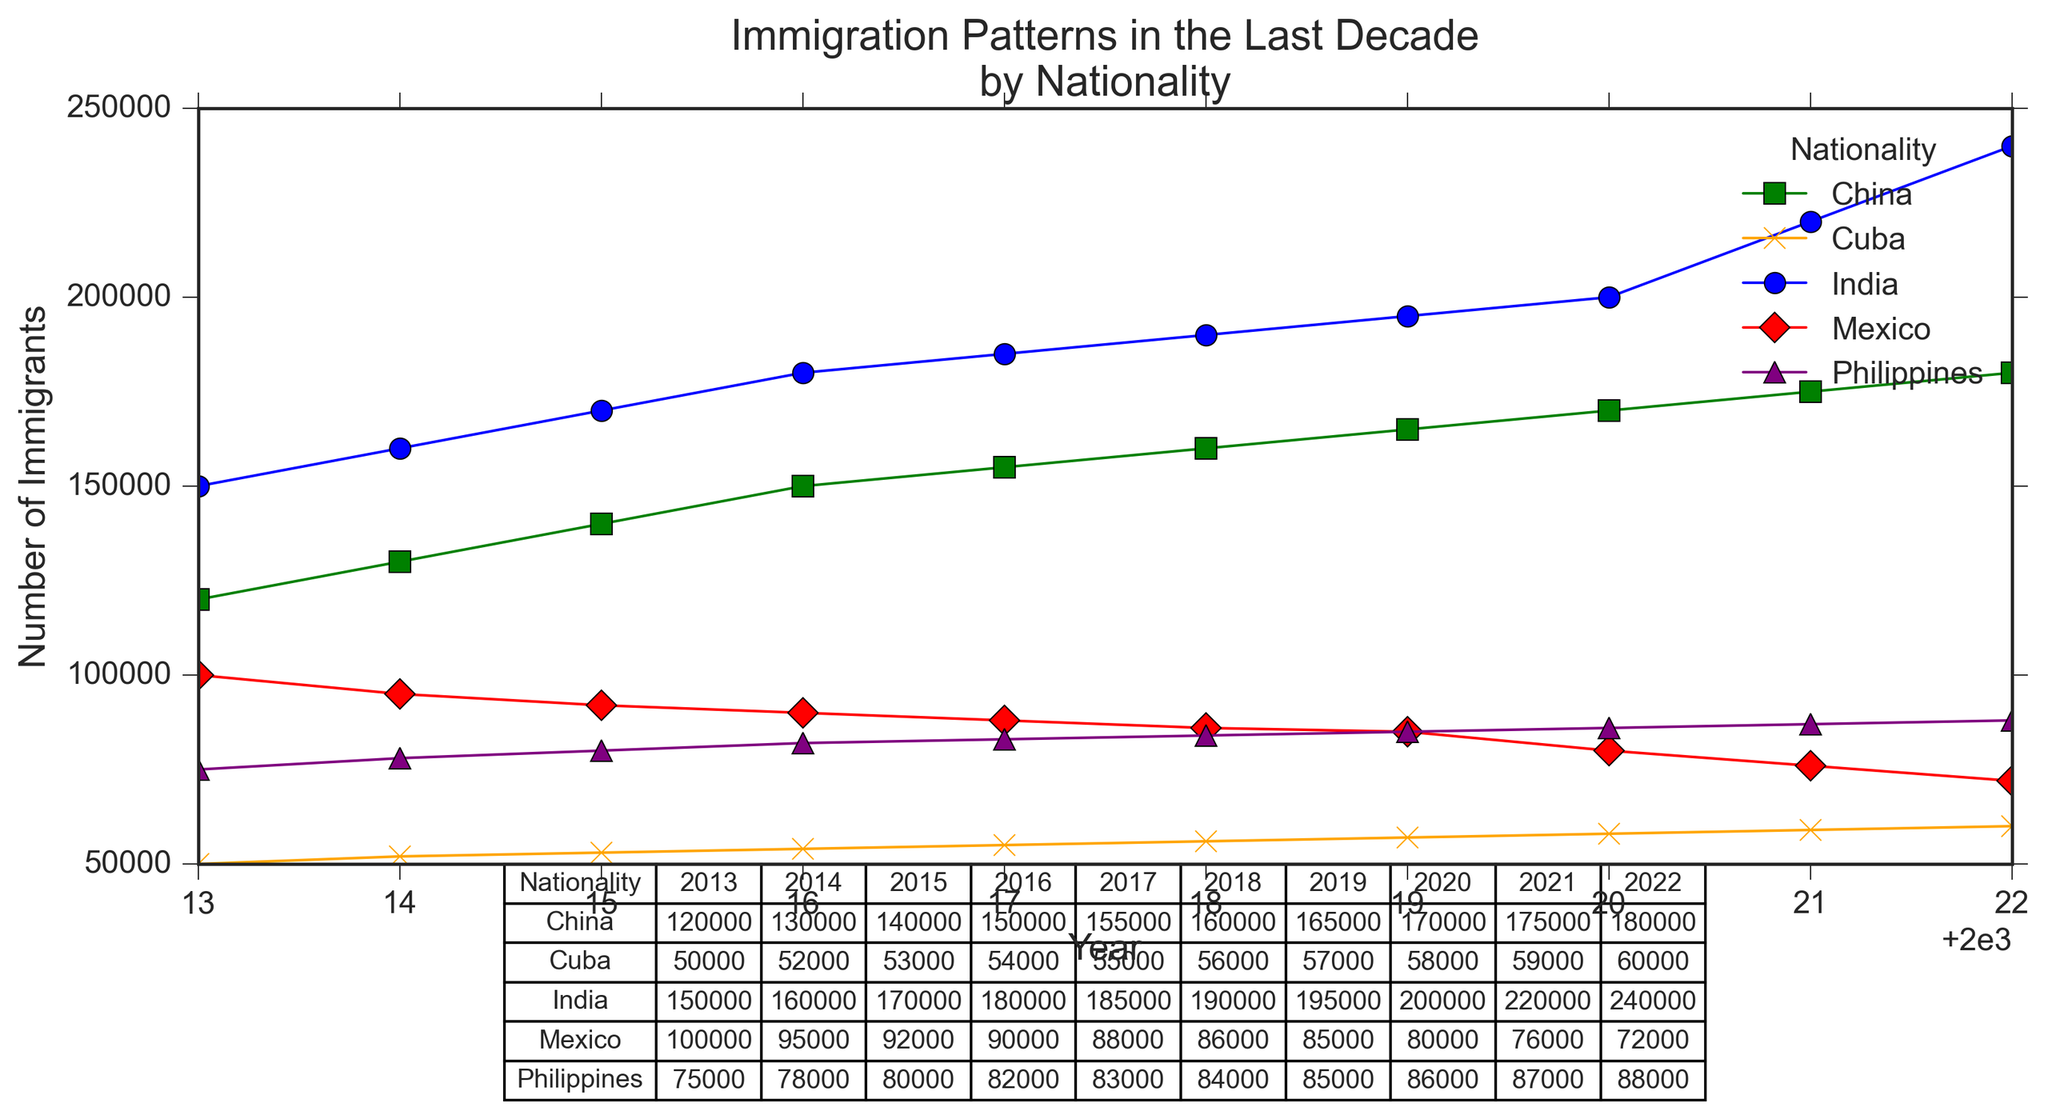What's the overall trend in the number of immigrants from India over the last decade? To determine the overall trend, look at the data points for India from 2013 to 2022 in the chart. The number of immigrants from India increases consistently every year. By observing the line plot for India, you can clearly see an upward trend.
Answer: Increasing Which nationality had the second-highest number of immigrants in 2022? By examining the table and the plotted data for 2022, we can see China had the second-highest number of immigrants at 180,000, just below India, which had 240,000.
Answer: China How many more immigrants came from the Philippines than Cuba in 2021? Look at the values for 2021 in the table: the Philippines had 87,000 immigrants, and Cuba had 59,000. Subtracting the number of immigrants from Cuba from those from the Philippines gives 87,000 - 59,000 = 28,000.
Answer: 28,000 During which year did Mexico see the largest decline in immigration numbers? To find the year with the largest decline, compare the year-over-year changes for Mexico. The largest decline appears between 2021 and 2022 where the number of immigrants decreased from 76,000 to 72,000, a decline of 4,000.
Answer: Between 2021 and 2022 Which nationality consistently shows the least variation in immigration numbers? By examining the variations in the lines for each nationality, Cuba shows the least variation. The line for Cuba is the flattest, indicating relatively stable numbers over the years.
Answer: Cuba What's the average number of immigrants from China over the decade? To calculate the average, sum the immigrant numbers for China from 2013 to 2022 (sum = 120,000 + 130,000 + 140,000 + 150,000 + 155,000 + 160,000 + 165,000 + 170,000 + 175,000 + 180,000 = 1,545,000) and divide by the number of years (10). Average = 1,545,000 / 10 = 154,500.
Answer: 154,500 In which year did the Philippines exceed 80,000 immigrants for the first time? Referring to the table and the plotted data, the Philippines exceeded 80,000 immigrants for the first time in 2016 when the number reached 82,000.
Answer: 2016 Compare the immigration growth rate of India and China from 2013 to 2022. For India, the number of immigrants increases from 150,000 in 2013 to 240,000 in 2022, an increase of 90,000. For China, the count goes from 120,000 in 2013 to 180,000 in 2022, an increase of 60,000. India shows a higher growth rate than China.
Answer: India has a higher growth rate What is the combined number of immigrants from Mexico and Cuba in 2020? Look at the values for 2020: Mexico has 80,000 immigrants and Cuba has 58,000. Adding these together gives 80,000 + 58,000 = 138,000.
Answer: 138,000 In which year did India surpass 200,000 immigrants? Referring to the plotted data and the table, India surpassed 200,000 immigrants in 2020 when the number reached exactly 200,000.
Answer: 2020 